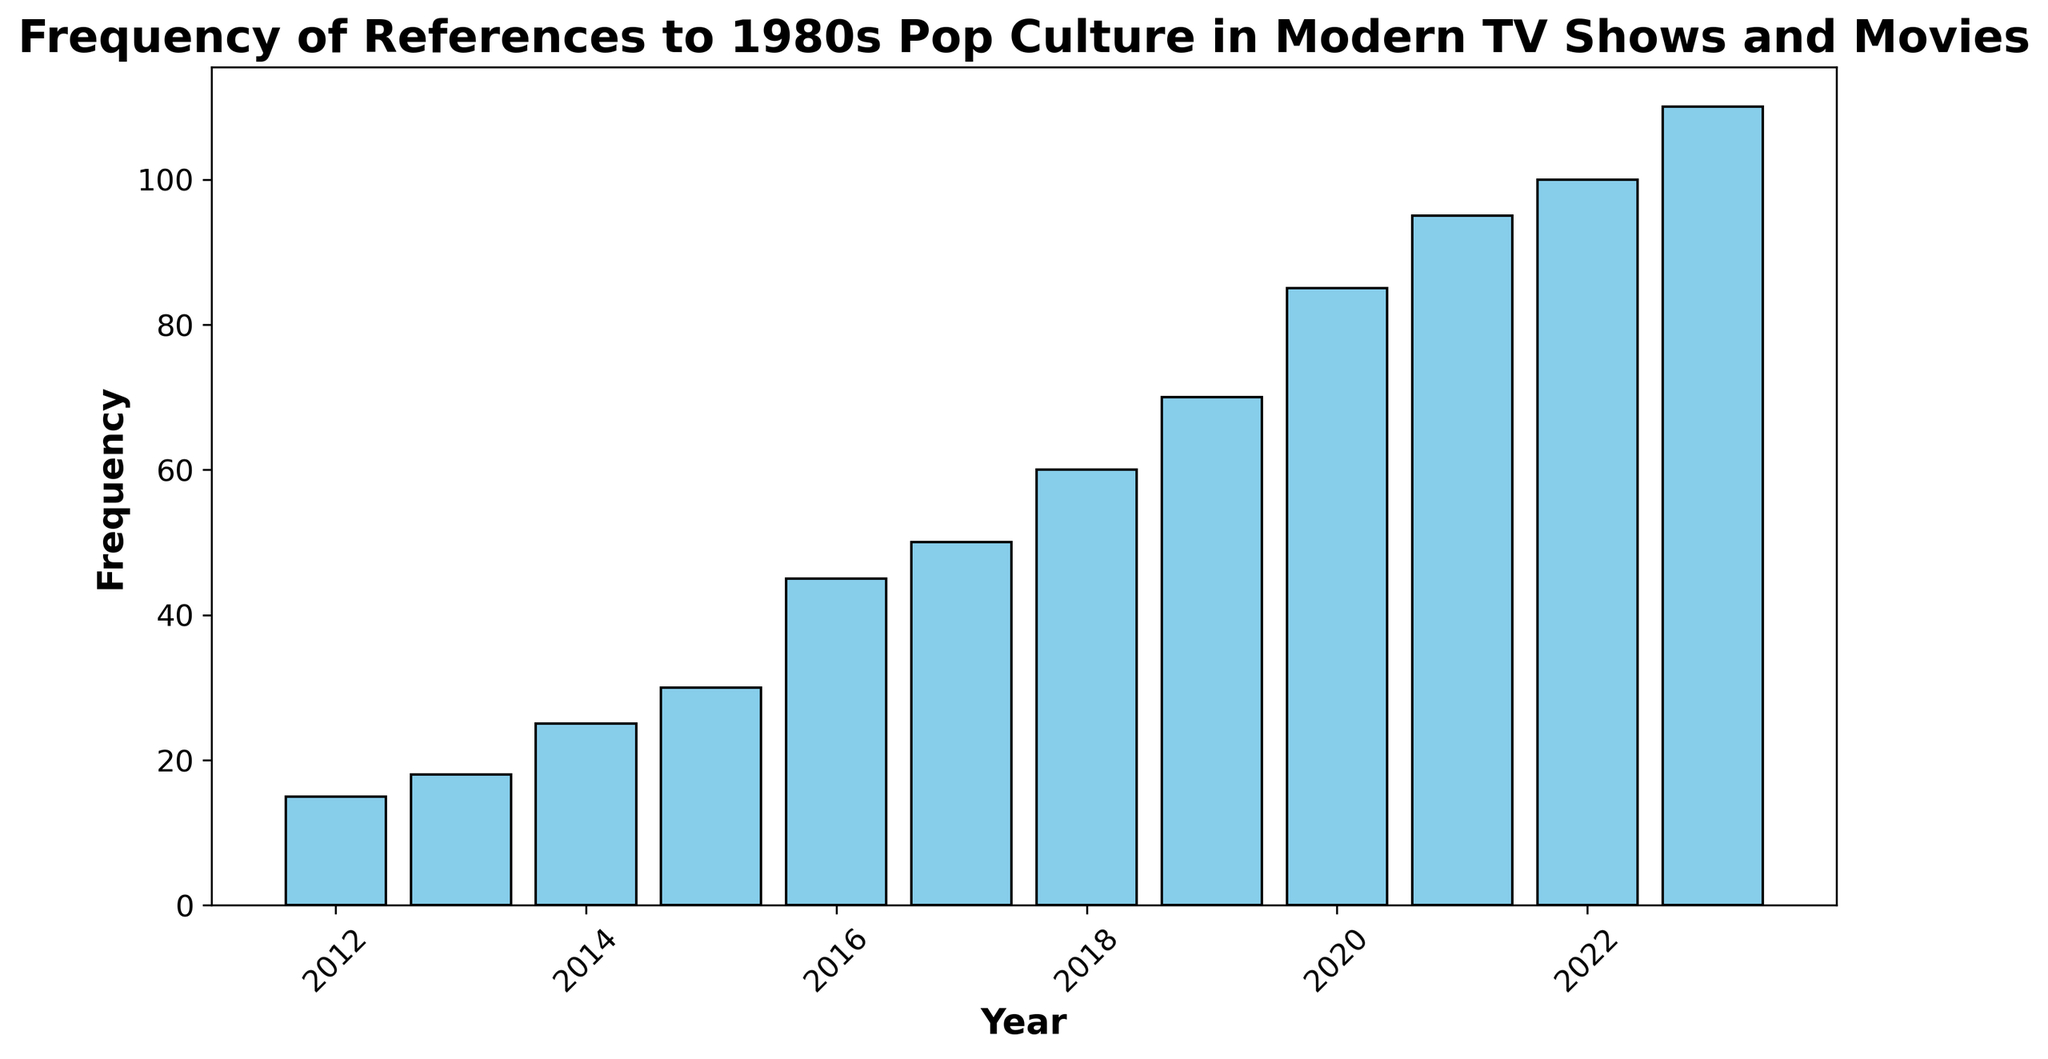What is the frequency of references in 2015? To determine the frequency of 1980s pop culture references in 2015, look directly at the bar corresponding to the year 2015 on the x-axis and note its height. This height represents the frequency for that year.
Answer: 30 How much has the frequency increased from 2012 to 2023? First, find the frequency for the year 2012 (15) and for 2023 (110). Then calculate the difference between these two values: 110 - 15. Therefore, the increase is 95.
Answer: 95 Which year shows the highest frequency of references? Scan the chart and identify the tallest bar. The year associated with this bar will have the highest frequency. In this case, the tallest bar corresponds to the year 2023.
Answer: 2023 How does the frequency in 2019 compare to that in 2017? Locate the bars for 2019 and 2017 on the chart. Check the heights of these bars to determine the frequencies: 2019 has 70 and 2017 has 50. Therefore, 2019 has a higher frequency than 2017.
Answer: 2019 has a higher frequency than 2017 What is the average frequency over the entire period shown? Add all the frequency values from 2012 to 2023: 15 + 18 + 25 + 30 + 45 + 50 + 60 + 70 + 85 + 95 + 100 + 110 = 703. There are 12 data points, so divide the total by 12: 703 / 12.
Answer: 58.58 Which year saw the largest single-year increase in frequency? Calculate the year-over-year differences for each consecutive year: 2013 - 2012 (3), 2014 - 2013 (7), 2015 - 2014 (5), 2016 - 2015 (15), 2017 - 2016 (5), 2018 - 2017 (10), 2019 - 2018 (10), 2020 - 2019 (15), 2021 - 2020 (10), 2022 - 2021 (5), 2023 - 2022 (10). The largest year-over-year increase is 15, which occurred from 2015 to 2016 and from 2019 to 2020.
Answer: 2015 to 2016 and 2019 to 2020 What percentage increase in frequency occurred from 2020 to 2023? Find the initial and final frequencies: 2020 (85) and 2023 (110). Calculate the difference: 110 - 85 = 25. The percentage increase is then (25 / 85) * 100.
Answer: 29.41% In which year did the frequency of references first exceed 50? Look for the first year where the height of the bar exceeds the midpoint value of 50. In 2017, the frequency reaches 50 and starts exceeding it in 2018.
Answer: 2018 What is the median frequency value over the years? List all frequencies in ascending order: 15, 18, 25, 30, 45, 50, 60, 70, 85, 95, 100, 110. The median is the middle value. With 12 data points, average the 6th and 7th values (50+60)/2.
Answer: 55 